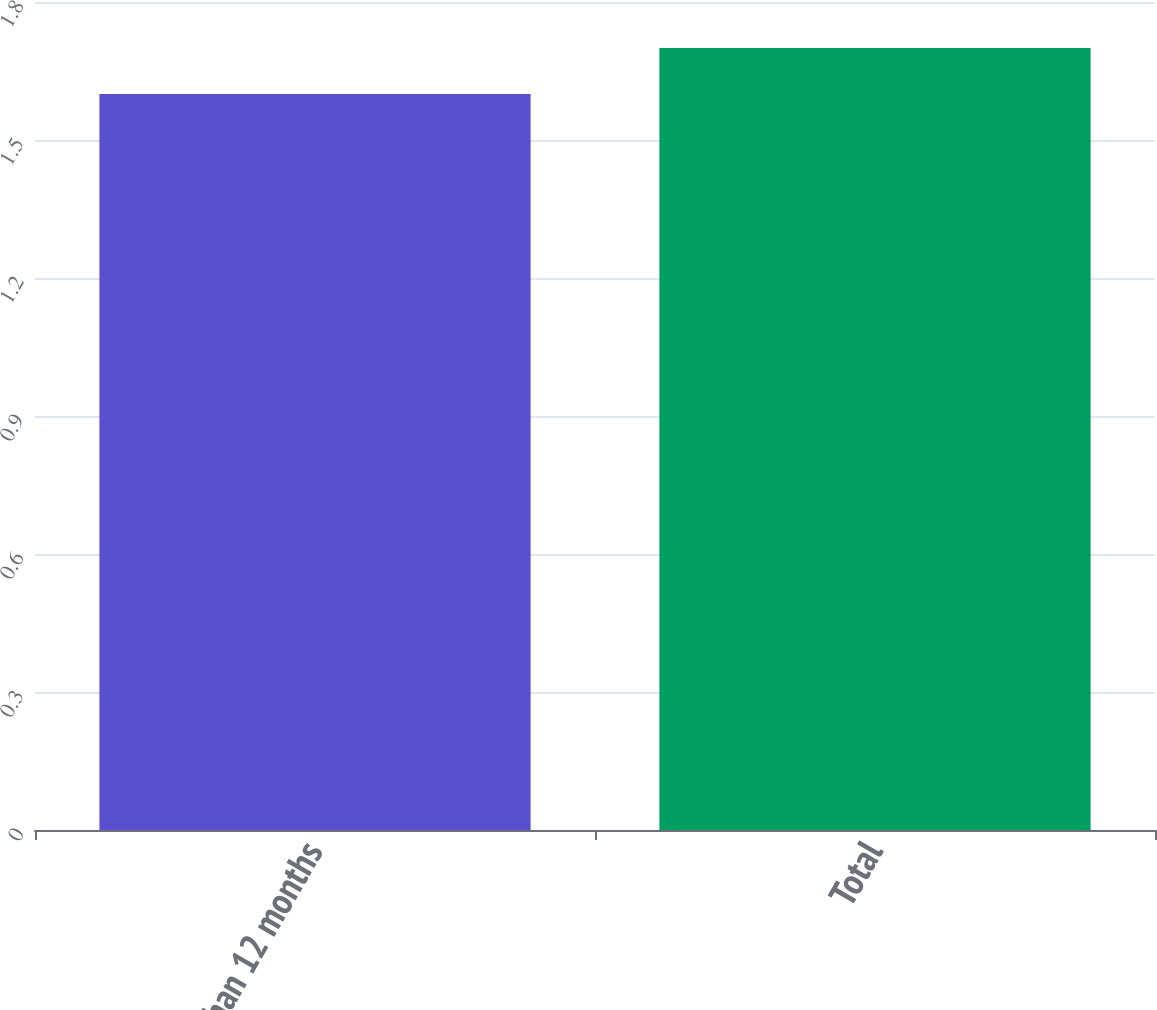Convert chart to OTSL. <chart><loc_0><loc_0><loc_500><loc_500><bar_chart><fcel>More than 12 months<fcel>Total<nl><fcel>1.6<fcel>1.7<nl></chart> 